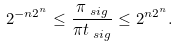Convert formula to latex. <formula><loc_0><loc_0><loc_500><loc_500>2 ^ { - n 2 ^ { n } } & \leq \frac { \pi _ { \ s i g } } { \pi t _ { \ s i g } } \leq 2 ^ { n 2 ^ { n } } .</formula> 